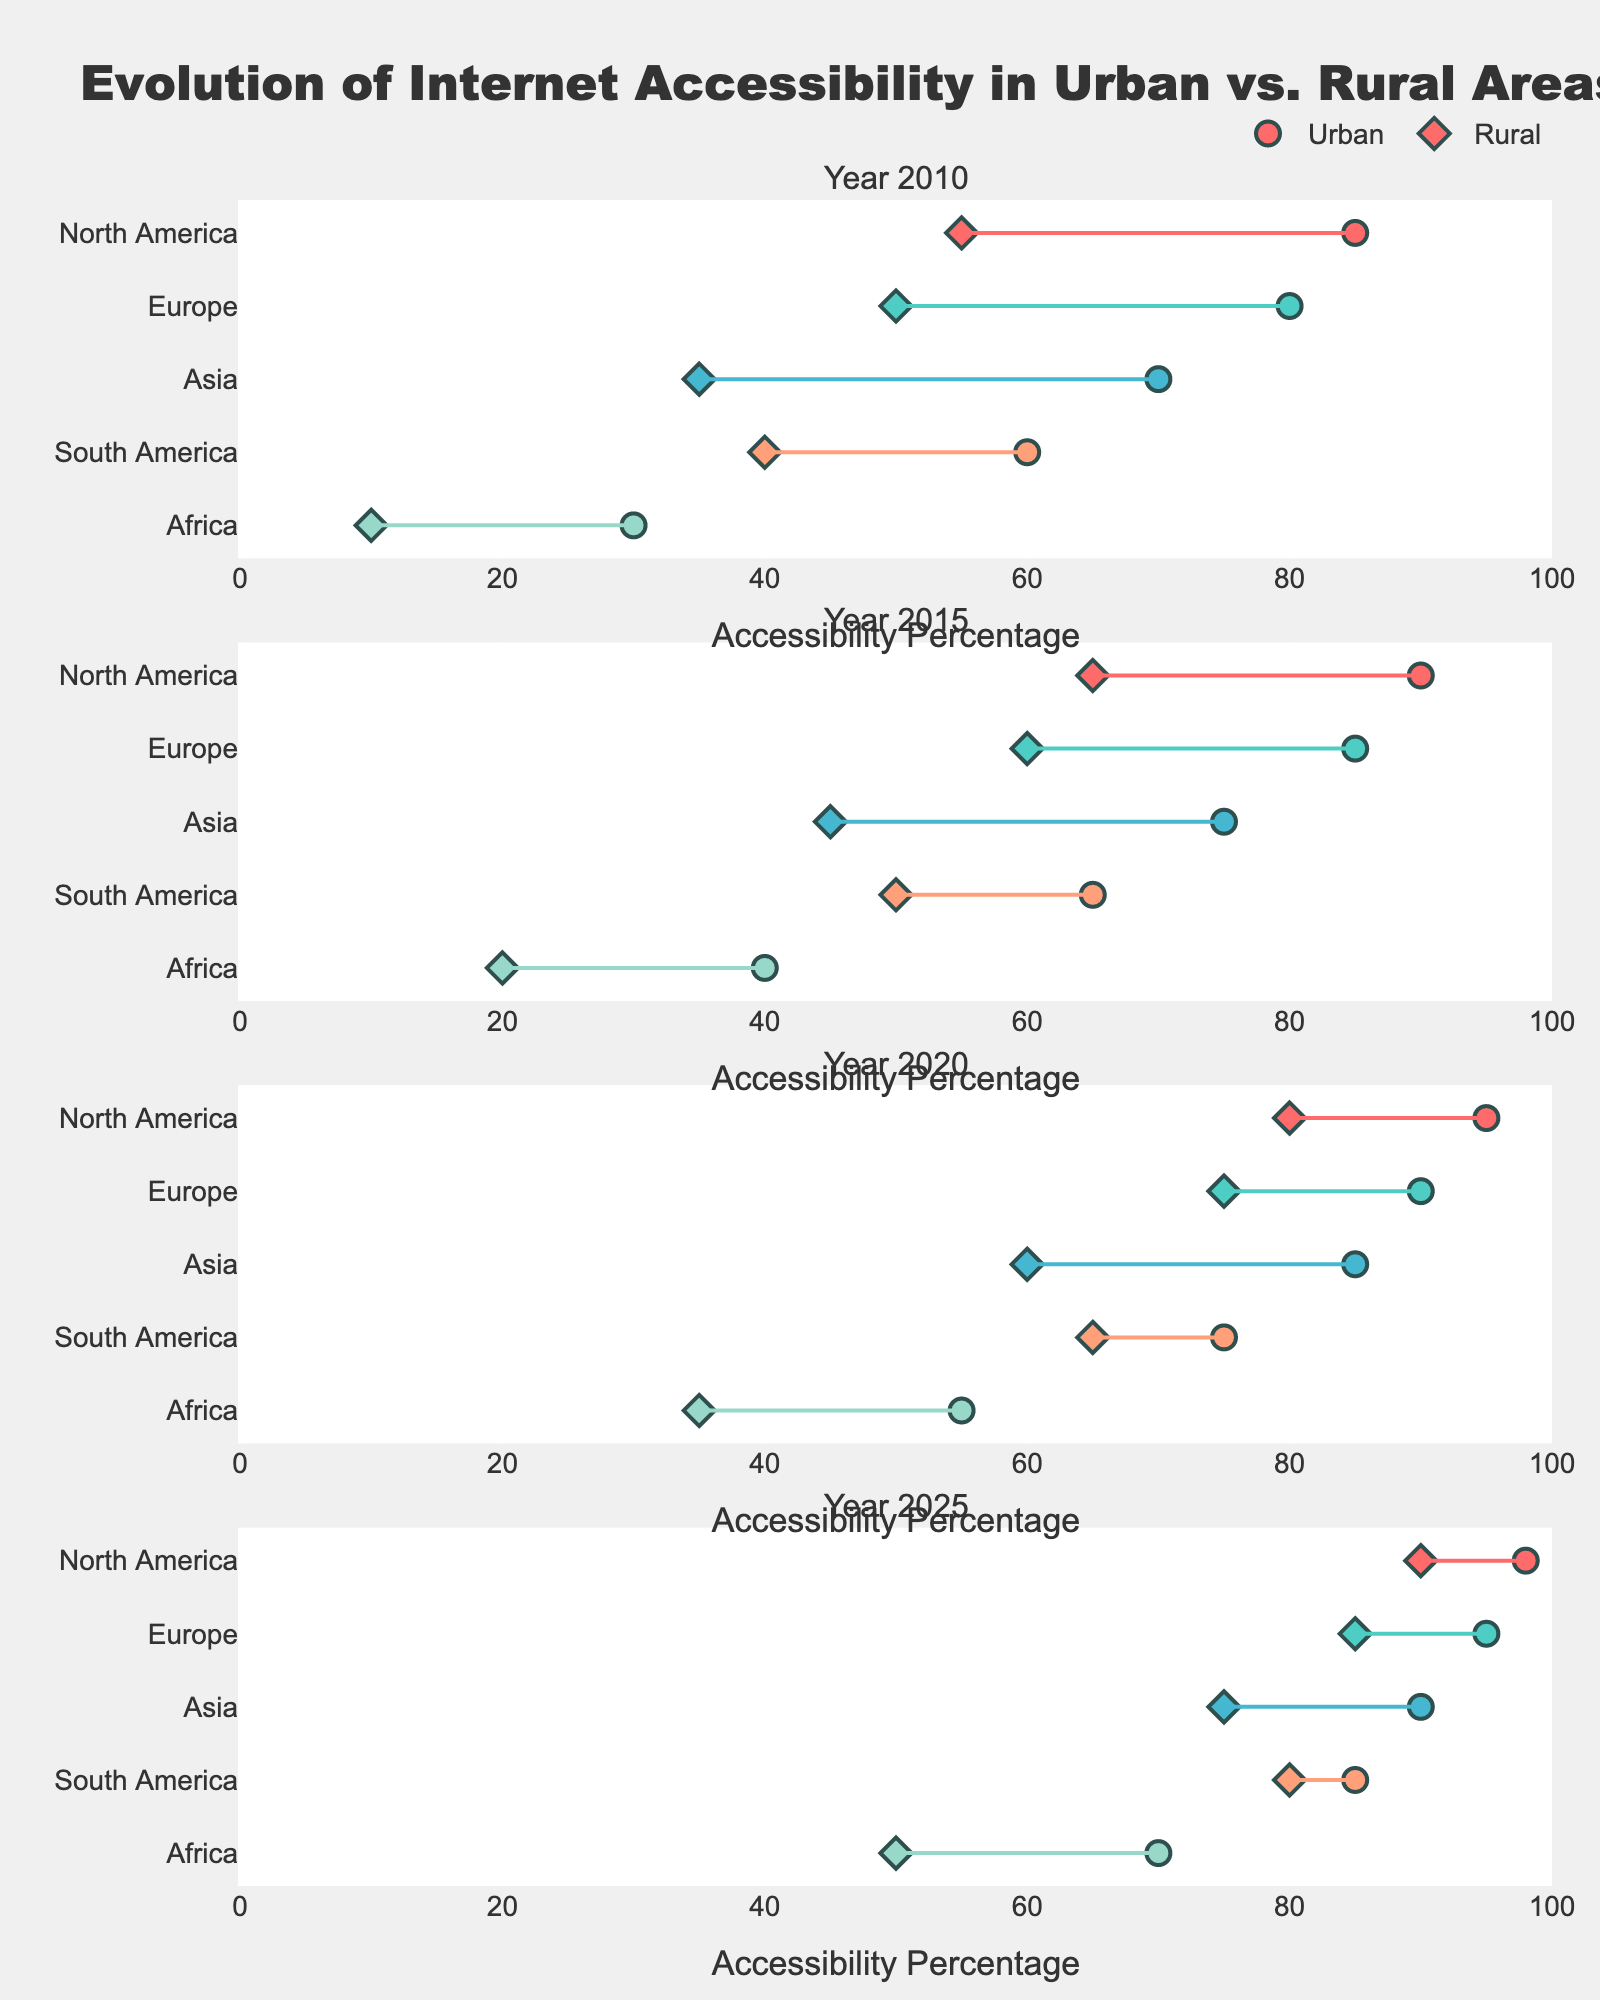What is the title of the plot? The title is prominently placed at the top of the plot and reads "Evolution of Internet Accessibility in Urban vs. Rural Areas".
Answer: Evolution of Internet Accessibility in Urban vs. Rural Areas What is the urban accessibility percentage for Europe in 2020? In the subplot for the year 2020, locate the purple circle marker for Europe on the x-axis. The urban accessibility percentage for Europe is indicated by this marker.
Answer: 90 Which region had the largest increase in rural internet accessibility from 2010 to 2025? Compare the rural accessibility percentages for each region between 2010 and 2025. Calculate the differences: North America (90-55=35), Europe (85-50=35), Asia (75-35=40), South America (80-40=40), Africa (50-10=40).
Answer: Africa, Asia, South America (all 40%) What is the difference in internet accessibility percentages between urban and rural areas in North America in 2010? Locate the two markers for North America in 2010 (urban and rural). Subtract the rural accessibility percentage from the urban percentage (85 - 55).
Answer: 30 Which region has the smallest gap between urban and rural accessibility in 2025? In the subplot for 2025, identify the length of the lines connecting the two markers for each region. The region with the shortest line has the smallest gap.
Answer: North America How has urban internet accessibility changed in Africa from 2010 to 2025? Track the purple circle marker for Africa in each subplot from 2010 to 2025. Note the urban accessibility percentages for these years: 30, 40, 55, 70.
Answer: Increased by 40 percentage points Comparing the rural accessibility in 2010 and 2025 for Asia, what is the percentage increase? Locate the diamond markers for Asia in 2010 and 2025. The percentages are 35 and 75, respectively. Calculate the increase (75 - 35) and then find the percentage increase: (40/35) * 100.
Answer: 114.29% In 2020, which region had the highest rural internet accessibility percentage? In the subplot for 2020, look for the diamond marker furthest to the right on the x-axis. This represents the highest rural accessibility.
Answer: North America Which year shows the smallest overall gap between urban and rural accessibility across all regions? Compare the gaps between urban and rural accessibility (markers and lines) for all regions in each subplot. The year with the shortest overall line lengths across the subplots indicates the smallest gap.
Answer: 2025 